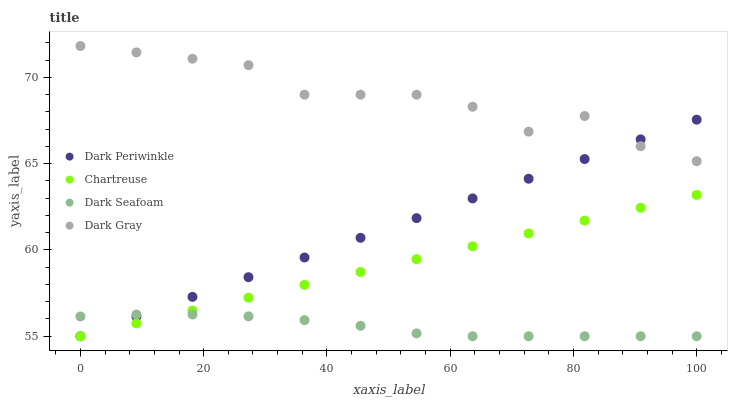Does Dark Seafoam have the minimum area under the curve?
Answer yes or no. Yes. Does Dark Gray have the maximum area under the curve?
Answer yes or no. Yes. Does Chartreuse have the minimum area under the curve?
Answer yes or no. No. Does Chartreuse have the maximum area under the curve?
Answer yes or no. No. Is Chartreuse the smoothest?
Answer yes or no. Yes. Is Dark Gray the roughest?
Answer yes or no. Yes. Is Dark Periwinkle the smoothest?
Answer yes or no. No. Is Dark Periwinkle the roughest?
Answer yes or no. No. Does Chartreuse have the lowest value?
Answer yes or no. Yes. Does Dark Gray have the highest value?
Answer yes or no. Yes. Does Chartreuse have the highest value?
Answer yes or no. No. Is Chartreuse less than Dark Gray?
Answer yes or no. Yes. Is Dark Gray greater than Chartreuse?
Answer yes or no. Yes. Does Dark Periwinkle intersect Chartreuse?
Answer yes or no. Yes. Is Dark Periwinkle less than Chartreuse?
Answer yes or no. No. Is Dark Periwinkle greater than Chartreuse?
Answer yes or no. No. Does Chartreuse intersect Dark Gray?
Answer yes or no. No. 